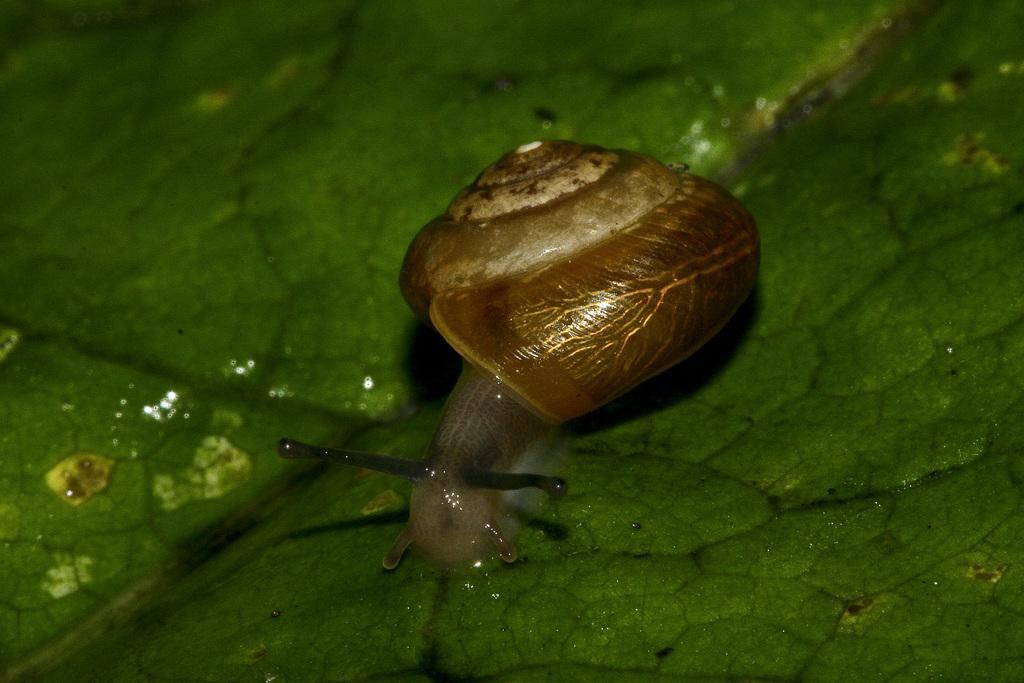Please provide a concise description of this image. In this image I see a snail over here which is on the green color thing. 